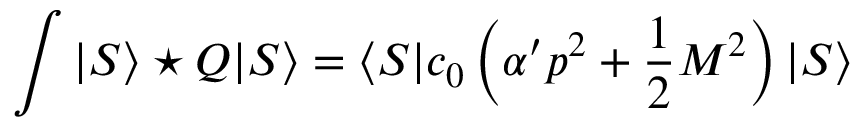Convert formula to latex. <formula><loc_0><loc_0><loc_500><loc_500>\int | S \rangle ^ { * } Q | S \rangle = \langle S | c _ { 0 } \left ( \alpha ^ { \prime } p ^ { 2 } + \frac { 1 } { 2 } M ^ { 2 } \right ) | S \rangle</formula> 